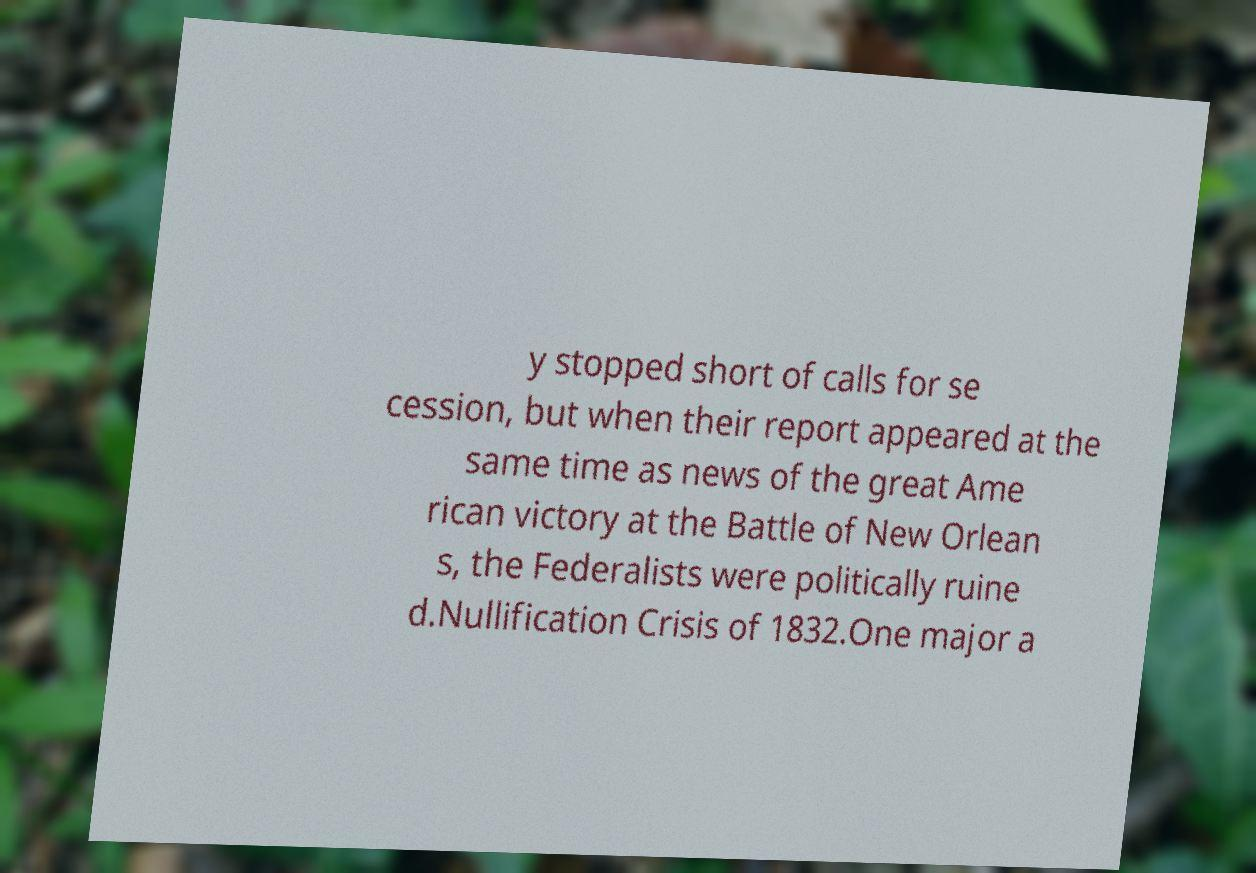Could you assist in decoding the text presented in this image and type it out clearly? y stopped short of calls for se cession, but when their report appeared at the same time as news of the great Ame rican victory at the Battle of New Orlean s, the Federalists were politically ruine d.Nullification Crisis of 1832.One major a 